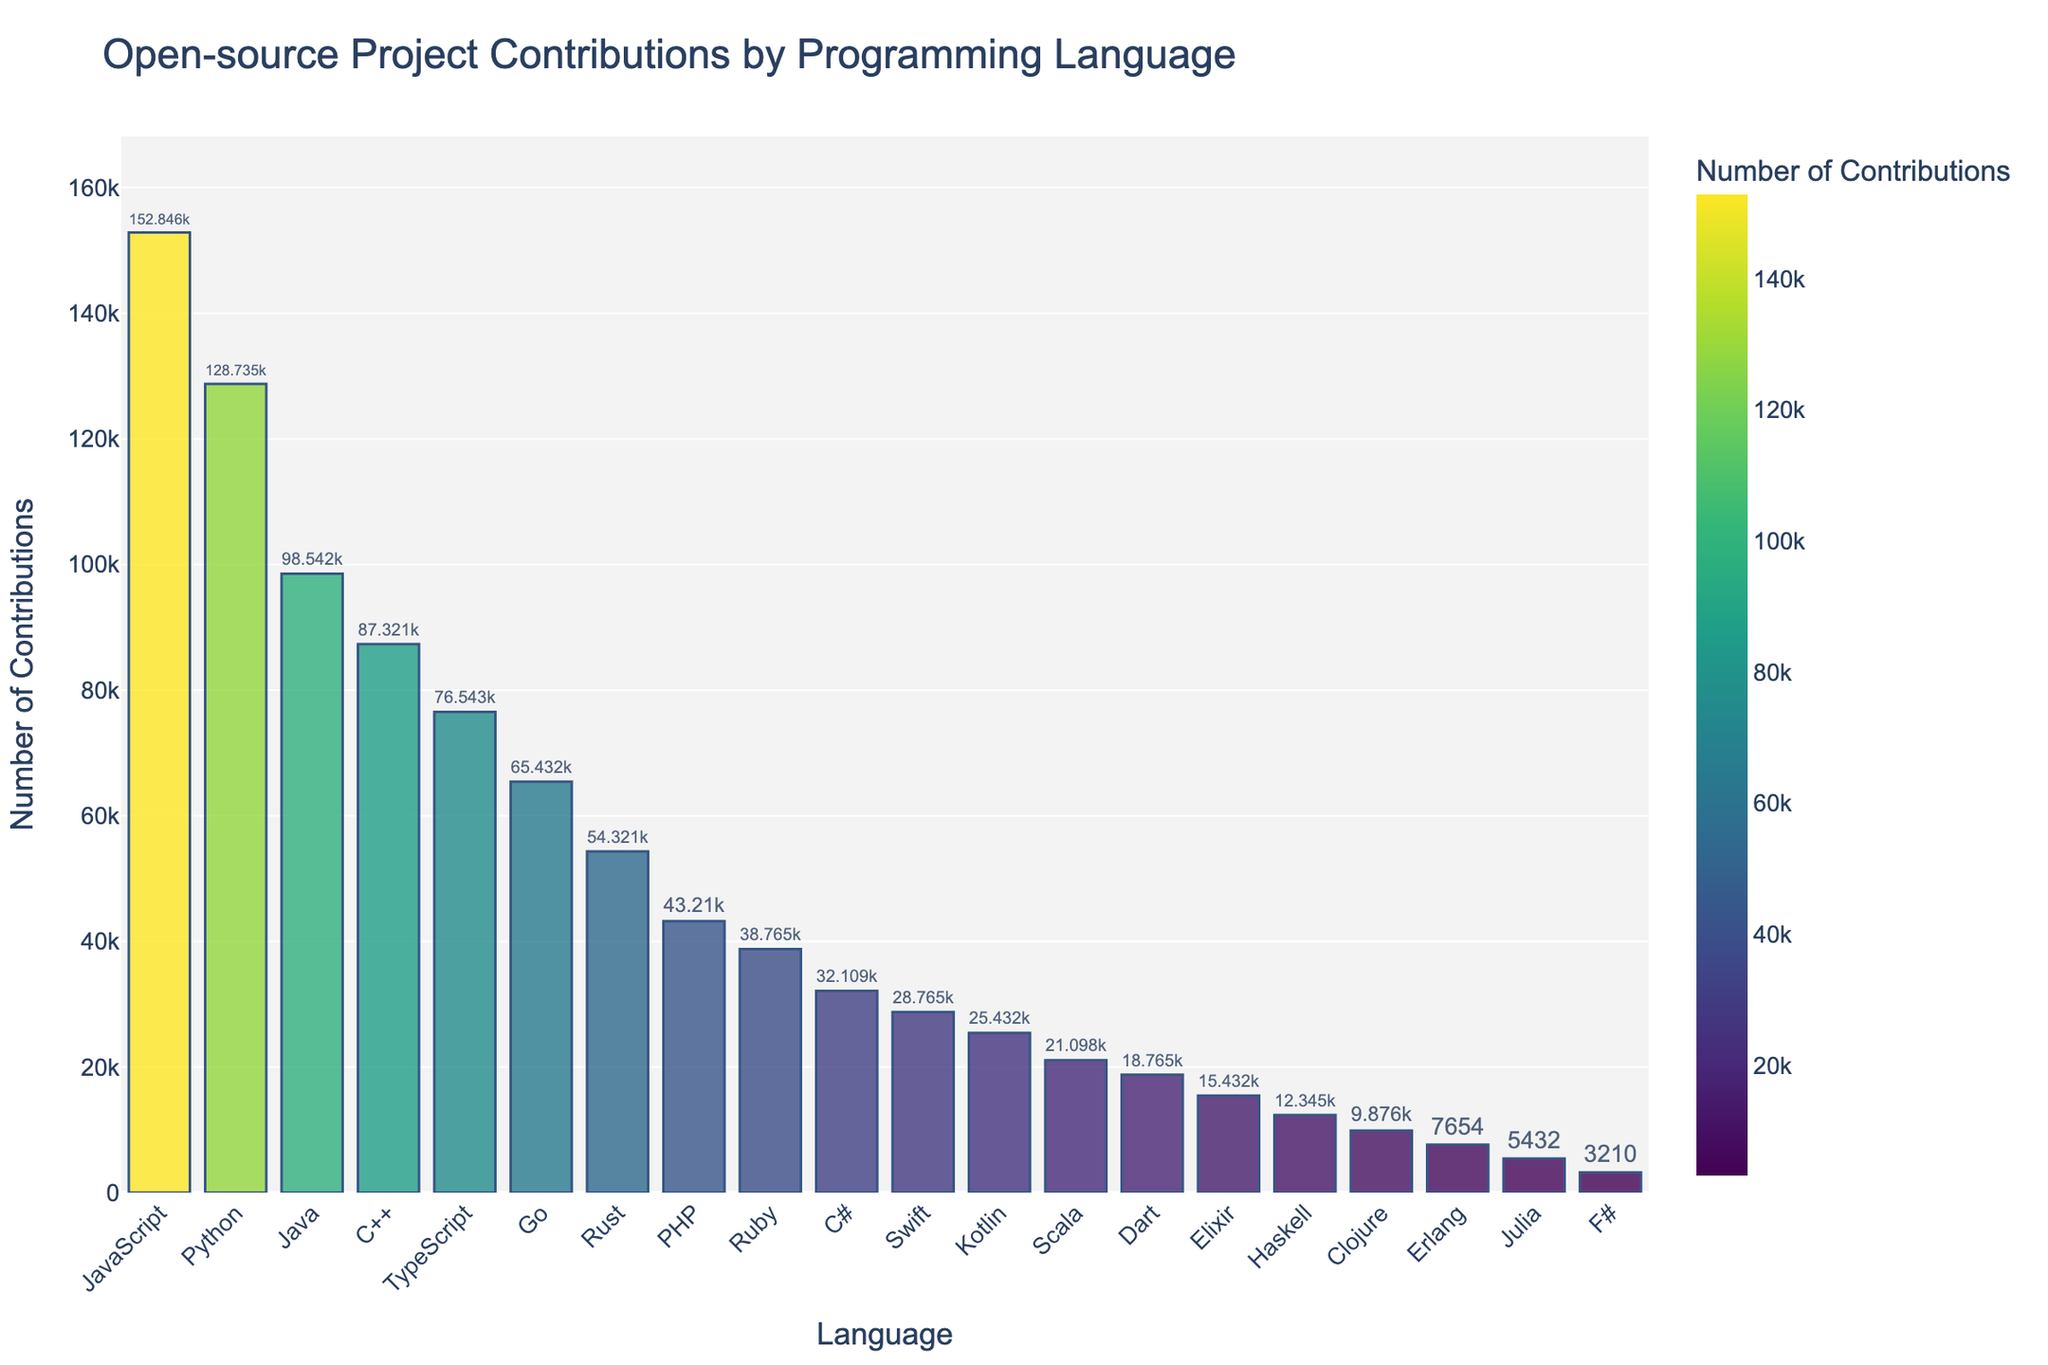Which programming language has the highest number of contributions? Look at the bar chart and identify the language with the tallest bar. JavaScript is at the top, showing it has the highest number of contributions.
Answer: JavaScript Which programming language has fewer contributions, Scala or Dart? Compare the heights of the bars for Scala and Dart. Scala's bar is taller, indicating it has more contributions. Thus, Dart has fewer contributions.
Answer: Dart What is the total number of contributions for JavaScript and Python combined? Sum the contributions for JavaScript (152846) and Python (128735). The combined total is 152846 + 128735 = 281581.
Answer: 281581 Which programming languages have contributions between 50,000 and 80,000? Identify the bars whose heights are between the values for 50,000 and 80,000 on the y-axis. TypeScript, Go, and Rust fall in this range.
Answer: TypeScript, Go, Rust How many contributions separate the language with the highest contributions from the language with the lowest contributions? Subtract the contributions for the language with the lowest (F# with 3210) from the language with the highest (JavaScript with 152846). The difference is 152846 - 3210 = 149636.
Answer: 149636 Which language has slightly more contributions, PHP or Ruby? Compare the bars for PHP and Ruby. PHP has a slightly taller bar, indicating it has more contributions.
Answer: PHP How much higher is the number of contributions for Java compared to Swift? Subtract the contributions for Swift (28765) from Java (98542). The difference is 98542 - 28765 = 69777.
Answer: 69777 Are there more contributions for TypeScript or Go? Compare the heights of the bars for TypeScript and Go. TypeScript has a taller bar, indicating more contributions.
Answer: TypeScript What is the average number of contributions for the top three languages? Sum the contributions for JavaScript (152846), Python (128735), and Java (98542), then divide by 3. The total is 379123; dividing by 3 gives 379123 / 3 = 126374.33.
Answer: 126374.33 Which languages have contributions greater than 100,000? Identify the bars that exceed the 100,000 mark on the y-axis. JavaScript and Python are above this threshold.
Answer: JavaScript, Python 